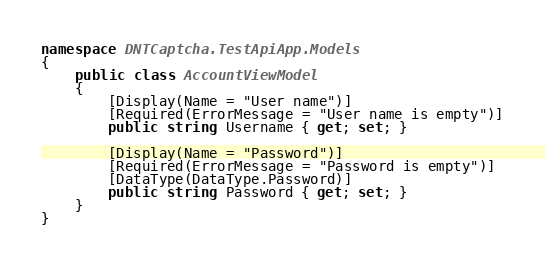Convert code to text. <code><loc_0><loc_0><loc_500><loc_500><_C#_>
namespace DNTCaptcha.TestApiApp.Models
{
    public class AccountViewModel
    {
        [Display(Name = "User name")]
        [Required(ErrorMessage = "User name is empty")]
        public string Username { get; set; }

        [Display(Name = "Password")]
        [Required(ErrorMessage = "Password is empty")]
        [DataType(DataType.Password)]
        public string Password { get; set; }
    }
}</code> 